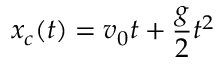Convert formula to latex. <formula><loc_0><loc_0><loc_500><loc_500>x _ { c } ( t ) = v _ { 0 } t + \frac { g } { 2 } t ^ { 2 }</formula> 